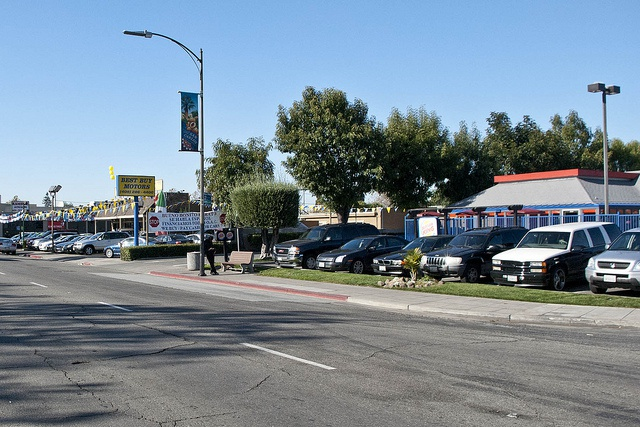Describe the objects in this image and their specific colors. I can see car in lightblue, black, white, navy, and gray tones, car in lightblue, black, gray, navy, and blue tones, car in lightblue, black, gray, navy, and blue tones, car in lightblue, black, white, darkgray, and gray tones, and car in lightblue, black, blue, navy, and gray tones in this image. 